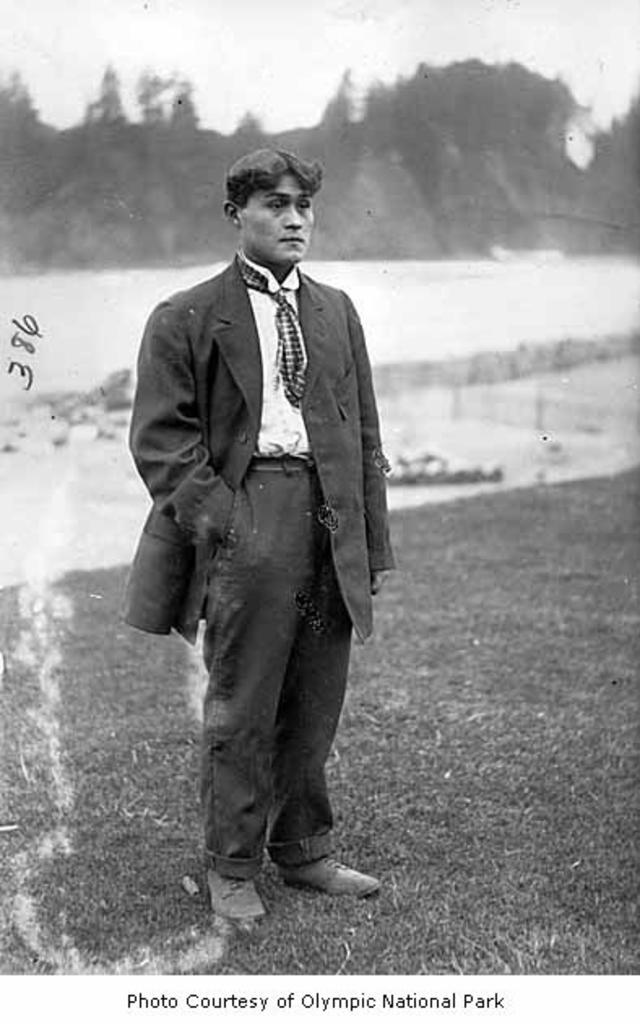What is the main subject of the image? There is a person standing in the image. What is the person wearing? The person is wearing a coat and a tie. What can be seen in the background of the image? There are trees in the background of the image. What is visible at the bottom of the image? There is ground visible at the bottom of the image. What else can be seen in the image besides the person? There is some text visible in the image. How many buns are being used for the test in the image? There is no mention of buns or a test in the image; it features a person standing with a coat and a tie, trees in the background, ground at the bottom, and some text. 